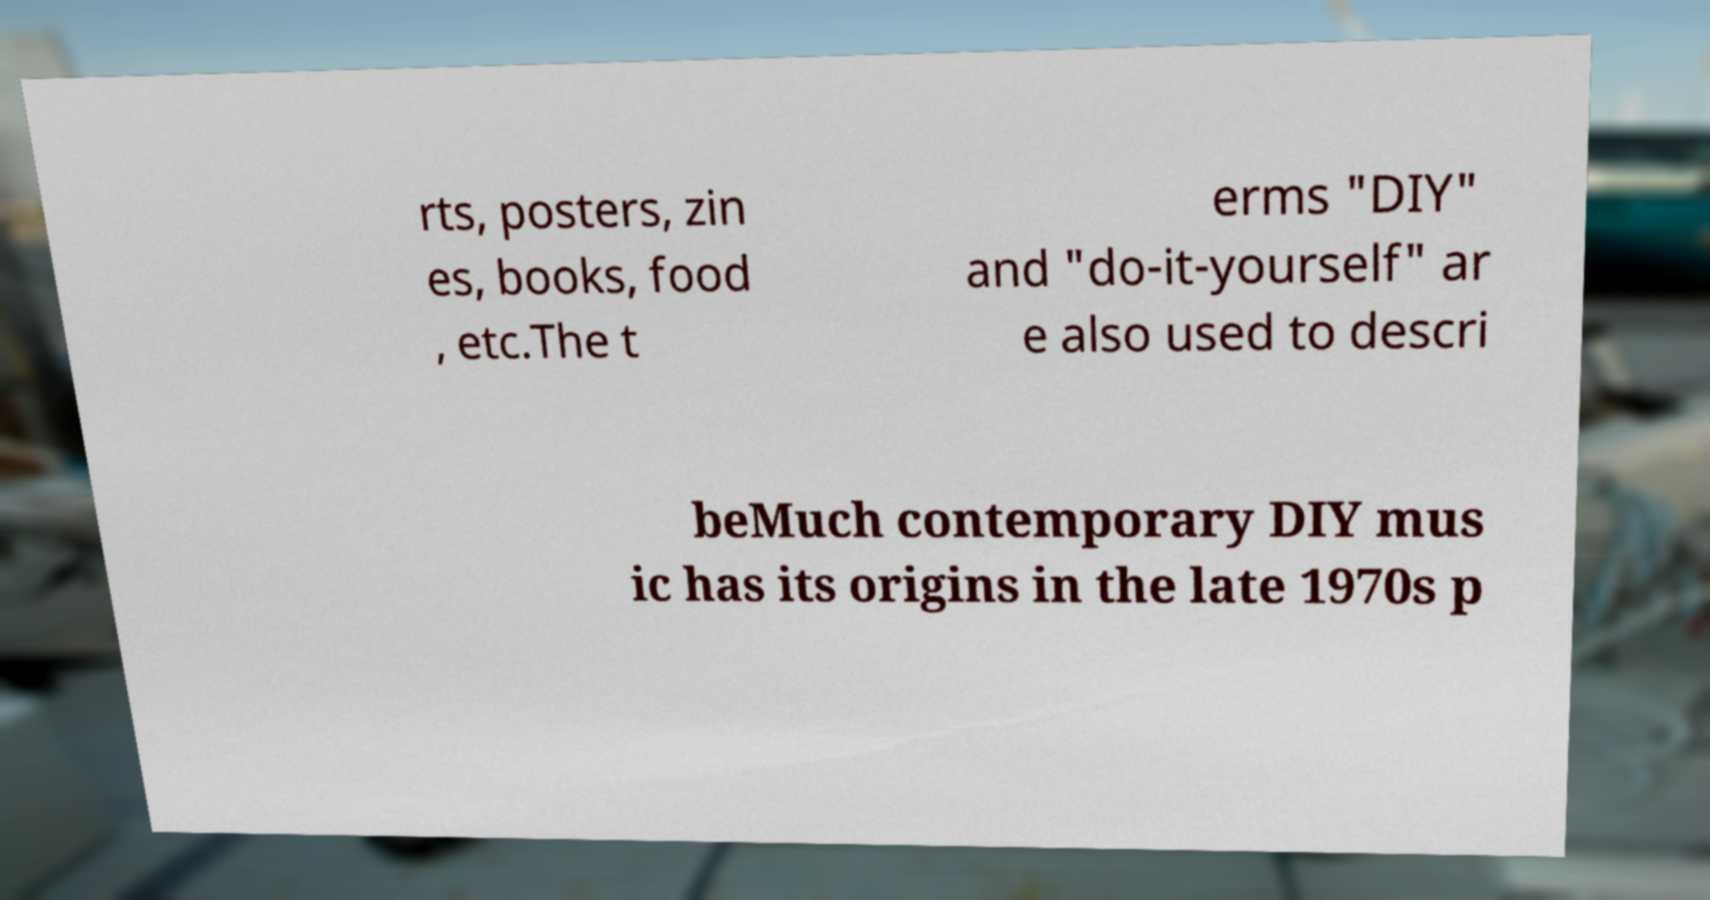Can you read and provide the text displayed in the image?This photo seems to have some interesting text. Can you extract and type it out for me? rts, posters, zin es, books, food , etc.The t erms "DIY" and "do-it-yourself" ar e also used to descri beMuch contemporary DIY mus ic has its origins in the late 1970s p 